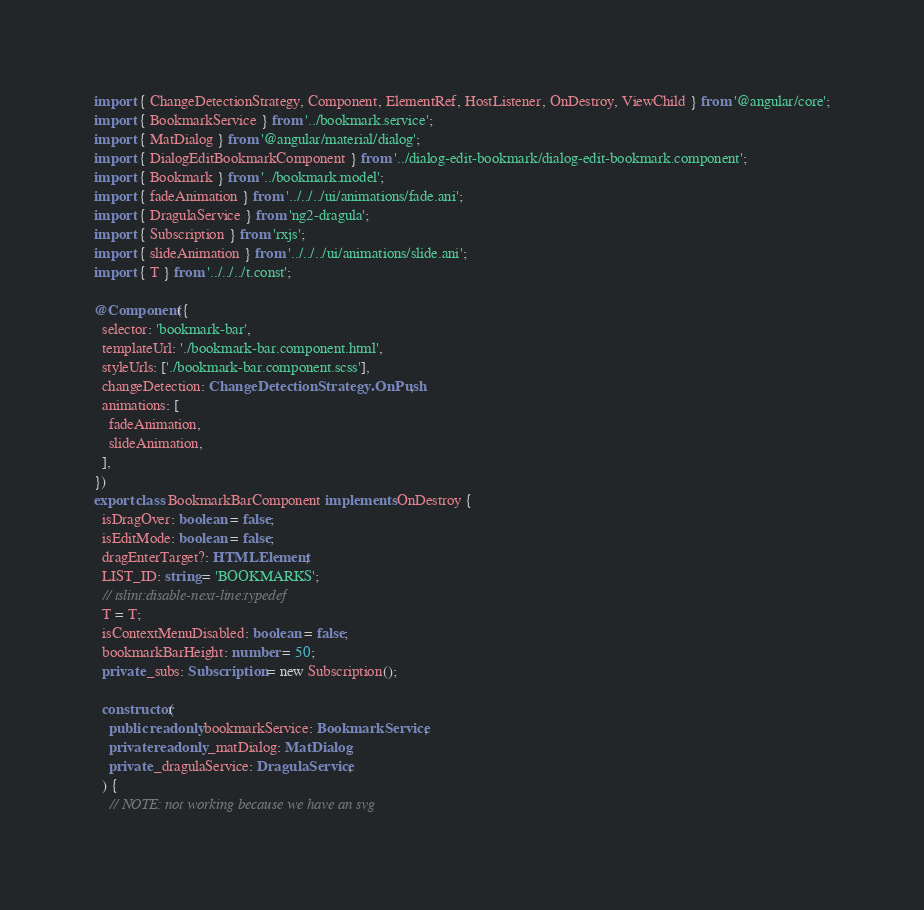Convert code to text. <code><loc_0><loc_0><loc_500><loc_500><_TypeScript_>import { ChangeDetectionStrategy, Component, ElementRef, HostListener, OnDestroy, ViewChild } from '@angular/core';
import { BookmarkService } from '../bookmark.service';
import { MatDialog } from '@angular/material/dialog';
import { DialogEditBookmarkComponent } from '../dialog-edit-bookmark/dialog-edit-bookmark.component';
import { Bookmark } from '../bookmark.model';
import { fadeAnimation } from '../../../ui/animations/fade.ani';
import { DragulaService } from 'ng2-dragula';
import { Subscription } from 'rxjs';
import { slideAnimation } from '../../../ui/animations/slide.ani';
import { T } from '../../../t.const';

@Component({
  selector: 'bookmark-bar',
  templateUrl: './bookmark-bar.component.html',
  styleUrls: ['./bookmark-bar.component.scss'],
  changeDetection: ChangeDetectionStrategy.OnPush,
  animations: [
    fadeAnimation,
    slideAnimation,
  ],
})
export class BookmarkBarComponent implements OnDestroy {
  isDragOver: boolean = false;
  isEditMode: boolean = false;
  dragEnterTarget?: HTMLElement;
  LIST_ID: string = 'BOOKMARKS';
  // tslint:disable-next-line:typedef
  T = T;
  isContextMenuDisabled: boolean = false;
  bookmarkBarHeight: number = 50;
  private _subs: Subscription = new Subscription();

  constructor(
    public readonly bookmarkService: BookmarkService,
    private readonly _matDialog: MatDialog,
    private _dragulaService: DragulaService,
  ) {
    // NOTE: not working because we have an svg</code> 